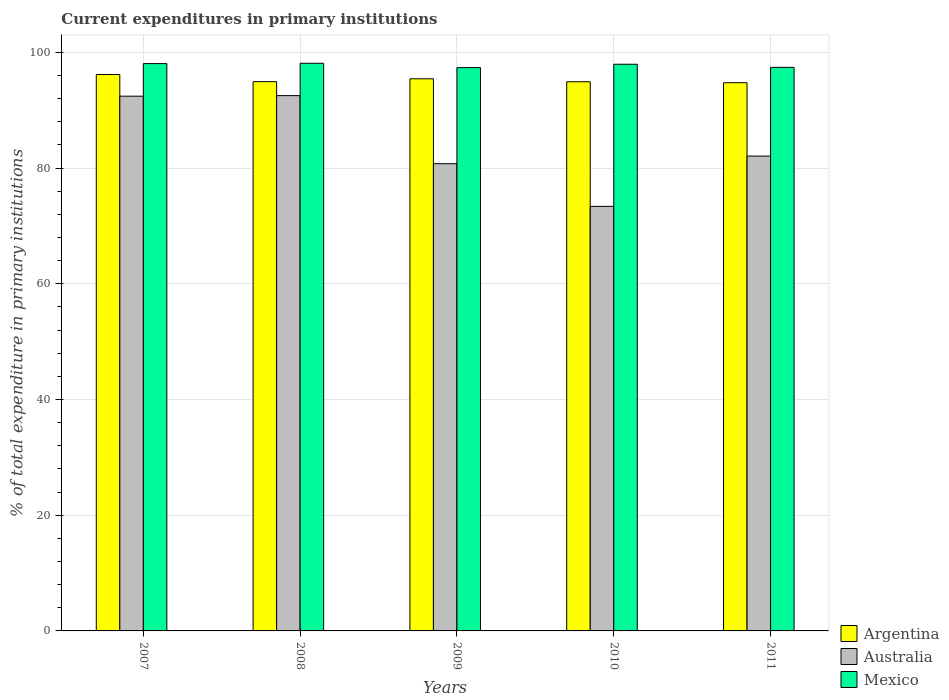Are the number of bars per tick equal to the number of legend labels?
Your answer should be compact. Yes. Are the number of bars on each tick of the X-axis equal?
Your response must be concise. Yes. How many bars are there on the 2nd tick from the left?
Your answer should be very brief. 3. How many bars are there on the 5th tick from the right?
Offer a terse response. 3. In how many cases, is the number of bars for a given year not equal to the number of legend labels?
Ensure brevity in your answer.  0. What is the current expenditures in primary institutions in Australia in 2011?
Ensure brevity in your answer.  82.07. Across all years, what is the maximum current expenditures in primary institutions in Mexico?
Your answer should be very brief. 98.11. Across all years, what is the minimum current expenditures in primary institutions in Australia?
Your answer should be very brief. 73.38. In which year was the current expenditures in primary institutions in Australia maximum?
Provide a short and direct response. 2008. What is the total current expenditures in primary institutions in Australia in the graph?
Make the answer very short. 421.15. What is the difference between the current expenditures in primary institutions in Mexico in 2008 and that in 2011?
Your response must be concise. 0.71. What is the difference between the current expenditures in primary institutions in Argentina in 2007 and the current expenditures in primary institutions in Mexico in 2010?
Offer a terse response. -1.77. What is the average current expenditures in primary institutions in Argentina per year?
Ensure brevity in your answer.  95.24. In the year 2011, what is the difference between the current expenditures in primary institutions in Argentina and current expenditures in primary institutions in Australia?
Your answer should be very brief. 12.68. What is the ratio of the current expenditures in primary institutions in Mexico in 2009 to that in 2011?
Make the answer very short. 1. Is the current expenditures in primary institutions in Australia in 2008 less than that in 2009?
Offer a very short reply. No. What is the difference between the highest and the second highest current expenditures in primary institutions in Argentina?
Provide a succinct answer. 0.74. What is the difference between the highest and the lowest current expenditures in primary institutions in Mexico?
Your answer should be very brief. 0.75. Is the sum of the current expenditures in primary institutions in Australia in 2008 and 2010 greater than the maximum current expenditures in primary institutions in Argentina across all years?
Offer a very short reply. Yes. What does the 2nd bar from the right in 2008 represents?
Provide a short and direct response. Australia. Is it the case that in every year, the sum of the current expenditures in primary institutions in Mexico and current expenditures in primary institutions in Argentina is greater than the current expenditures in primary institutions in Australia?
Provide a short and direct response. Yes. Are all the bars in the graph horizontal?
Give a very brief answer. No. How many years are there in the graph?
Your answer should be very brief. 5. Does the graph contain grids?
Provide a short and direct response. Yes. Where does the legend appear in the graph?
Your response must be concise. Bottom right. How many legend labels are there?
Ensure brevity in your answer.  3. How are the legend labels stacked?
Ensure brevity in your answer.  Vertical. What is the title of the graph?
Your answer should be very brief. Current expenditures in primary institutions. What is the label or title of the X-axis?
Keep it short and to the point. Years. What is the label or title of the Y-axis?
Offer a terse response. % of total expenditure in primary institutions. What is the % of total expenditure in primary institutions of Argentina in 2007?
Provide a succinct answer. 96.17. What is the % of total expenditure in primary institutions in Australia in 2007?
Keep it short and to the point. 92.42. What is the % of total expenditure in primary institutions of Mexico in 2007?
Ensure brevity in your answer.  98.05. What is the % of total expenditure in primary institutions of Argentina in 2008?
Provide a short and direct response. 94.93. What is the % of total expenditure in primary institutions in Australia in 2008?
Offer a very short reply. 92.52. What is the % of total expenditure in primary institutions of Mexico in 2008?
Your answer should be very brief. 98.11. What is the % of total expenditure in primary institutions of Argentina in 2009?
Provide a short and direct response. 95.43. What is the % of total expenditure in primary institutions in Australia in 2009?
Make the answer very short. 80.75. What is the % of total expenditure in primary institutions in Mexico in 2009?
Provide a succinct answer. 97.36. What is the % of total expenditure in primary institutions in Argentina in 2010?
Give a very brief answer. 94.92. What is the % of total expenditure in primary institutions of Australia in 2010?
Your response must be concise. 73.38. What is the % of total expenditure in primary institutions of Mexico in 2010?
Make the answer very short. 97.94. What is the % of total expenditure in primary institutions in Argentina in 2011?
Give a very brief answer. 94.75. What is the % of total expenditure in primary institutions of Australia in 2011?
Your response must be concise. 82.07. What is the % of total expenditure in primary institutions in Mexico in 2011?
Make the answer very short. 97.4. Across all years, what is the maximum % of total expenditure in primary institutions of Argentina?
Make the answer very short. 96.17. Across all years, what is the maximum % of total expenditure in primary institutions of Australia?
Offer a very short reply. 92.52. Across all years, what is the maximum % of total expenditure in primary institutions of Mexico?
Ensure brevity in your answer.  98.11. Across all years, what is the minimum % of total expenditure in primary institutions in Argentina?
Offer a very short reply. 94.75. Across all years, what is the minimum % of total expenditure in primary institutions of Australia?
Keep it short and to the point. 73.38. Across all years, what is the minimum % of total expenditure in primary institutions of Mexico?
Make the answer very short. 97.36. What is the total % of total expenditure in primary institutions in Argentina in the graph?
Offer a very short reply. 476.2. What is the total % of total expenditure in primary institutions of Australia in the graph?
Provide a short and direct response. 421.15. What is the total % of total expenditure in primary institutions of Mexico in the graph?
Make the answer very short. 488.87. What is the difference between the % of total expenditure in primary institutions of Argentina in 2007 and that in 2008?
Provide a short and direct response. 1.23. What is the difference between the % of total expenditure in primary institutions of Australia in 2007 and that in 2008?
Offer a terse response. -0.1. What is the difference between the % of total expenditure in primary institutions of Mexico in 2007 and that in 2008?
Give a very brief answer. -0.06. What is the difference between the % of total expenditure in primary institutions in Argentina in 2007 and that in 2009?
Offer a terse response. 0.74. What is the difference between the % of total expenditure in primary institutions of Australia in 2007 and that in 2009?
Your response must be concise. 11.67. What is the difference between the % of total expenditure in primary institutions in Mexico in 2007 and that in 2009?
Give a very brief answer. 0.69. What is the difference between the % of total expenditure in primary institutions in Argentina in 2007 and that in 2010?
Provide a succinct answer. 1.25. What is the difference between the % of total expenditure in primary institutions in Australia in 2007 and that in 2010?
Keep it short and to the point. 19.04. What is the difference between the % of total expenditure in primary institutions of Mexico in 2007 and that in 2010?
Provide a short and direct response. 0.11. What is the difference between the % of total expenditure in primary institutions of Argentina in 2007 and that in 2011?
Offer a terse response. 1.42. What is the difference between the % of total expenditure in primary institutions of Australia in 2007 and that in 2011?
Give a very brief answer. 10.35. What is the difference between the % of total expenditure in primary institutions of Mexico in 2007 and that in 2011?
Your answer should be compact. 0.65. What is the difference between the % of total expenditure in primary institutions of Argentina in 2008 and that in 2009?
Your answer should be compact. -0.5. What is the difference between the % of total expenditure in primary institutions in Australia in 2008 and that in 2009?
Give a very brief answer. 11.77. What is the difference between the % of total expenditure in primary institutions in Mexico in 2008 and that in 2009?
Keep it short and to the point. 0.75. What is the difference between the % of total expenditure in primary institutions in Argentina in 2008 and that in 2010?
Make the answer very short. 0.01. What is the difference between the % of total expenditure in primary institutions of Australia in 2008 and that in 2010?
Give a very brief answer. 19.14. What is the difference between the % of total expenditure in primary institutions in Mexico in 2008 and that in 2010?
Ensure brevity in your answer.  0.17. What is the difference between the % of total expenditure in primary institutions of Argentina in 2008 and that in 2011?
Your answer should be very brief. 0.19. What is the difference between the % of total expenditure in primary institutions in Australia in 2008 and that in 2011?
Provide a short and direct response. 10.45. What is the difference between the % of total expenditure in primary institutions in Mexico in 2008 and that in 2011?
Provide a short and direct response. 0.71. What is the difference between the % of total expenditure in primary institutions in Argentina in 2009 and that in 2010?
Provide a succinct answer. 0.51. What is the difference between the % of total expenditure in primary institutions of Australia in 2009 and that in 2010?
Give a very brief answer. 7.38. What is the difference between the % of total expenditure in primary institutions in Mexico in 2009 and that in 2010?
Provide a succinct answer. -0.58. What is the difference between the % of total expenditure in primary institutions of Argentina in 2009 and that in 2011?
Keep it short and to the point. 0.68. What is the difference between the % of total expenditure in primary institutions of Australia in 2009 and that in 2011?
Make the answer very short. -1.31. What is the difference between the % of total expenditure in primary institutions of Mexico in 2009 and that in 2011?
Offer a very short reply. -0.04. What is the difference between the % of total expenditure in primary institutions of Argentina in 2010 and that in 2011?
Your answer should be compact. 0.17. What is the difference between the % of total expenditure in primary institutions of Australia in 2010 and that in 2011?
Your answer should be very brief. -8.69. What is the difference between the % of total expenditure in primary institutions in Mexico in 2010 and that in 2011?
Provide a short and direct response. 0.54. What is the difference between the % of total expenditure in primary institutions in Argentina in 2007 and the % of total expenditure in primary institutions in Australia in 2008?
Give a very brief answer. 3.65. What is the difference between the % of total expenditure in primary institutions in Argentina in 2007 and the % of total expenditure in primary institutions in Mexico in 2008?
Ensure brevity in your answer.  -1.94. What is the difference between the % of total expenditure in primary institutions of Australia in 2007 and the % of total expenditure in primary institutions of Mexico in 2008?
Provide a short and direct response. -5.69. What is the difference between the % of total expenditure in primary institutions of Argentina in 2007 and the % of total expenditure in primary institutions of Australia in 2009?
Provide a short and direct response. 15.41. What is the difference between the % of total expenditure in primary institutions of Argentina in 2007 and the % of total expenditure in primary institutions of Mexico in 2009?
Offer a very short reply. -1.19. What is the difference between the % of total expenditure in primary institutions of Australia in 2007 and the % of total expenditure in primary institutions of Mexico in 2009?
Keep it short and to the point. -4.94. What is the difference between the % of total expenditure in primary institutions of Argentina in 2007 and the % of total expenditure in primary institutions of Australia in 2010?
Make the answer very short. 22.79. What is the difference between the % of total expenditure in primary institutions of Argentina in 2007 and the % of total expenditure in primary institutions of Mexico in 2010?
Provide a succinct answer. -1.77. What is the difference between the % of total expenditure in primary institutions of Australia in 2007 and the % of total expenditure in primary institutions of Mexico in 2010?
Offer a terse response. -5.52. What is the difference between the % of total expenditure in primary institutions in Argentina in 2007 and the % of total expenditure in primary institutions in Australia in 2011?
Your response must be concise. 14.1. What is the difference between the % of total expenditure in primary institutions in Argentina in 2007 and the % of total expenditure in primary institutions in Mexico in 2011?
Offer a terse response. -1.24. What is the difference between the % of total expenditure in primary institutions of Australia in 2007 and the % of total expenditure in primary institutions of Mexico in 2011?
Provide a short and direct response. -4.98. What is the difference between the % of total expenditure in primary institutions in Argentina in 2008 and the % of total expenditure in primary institutions in Australia in 2009?
Keep it short and to the point. 14.18. What is the difference between the % of total expenditure in primary institutions of Argentina in 2008 and the % of total expenditure in primary institutions of Mexico in 2009?
Ensure brevity in your answer.  -2.43. What is the difference between the % of total expenditure in primary institutions in Australia in 2008 and the % of total expenditure in primary institutions in Mexico in 2009?
Your response must be concise. -4.84. What is the difference between the % of total expenditure in primary institutions of Argentina in 2008 and the % of total expenditure in primary institutions of Australia in 2010?
Keep it short and to the point. 21.55. What is the difference between the % of total expenditure in primary institutions in Argentina in 2008 and the % of total expenditure in primary institutions in Mexico in 2010?
Keep it short and to the point. -3.01. What is the difference between the % of total expenditure in primary institutions of Australia in 2008 and the % of total expenditure in primary institutions of Mexico in 2010?
Offer a terse response. -5.42. What is the difference between the % of total expenditure in primary institutions in Argentina in 2008 and the % of total expenditure in primary institutions in Australia in 2011?
Provide a short and direct response. 12.86. What is the difference between the % of total expenditure in primary institutions in Argentina in 2008 and the % of total expenditure in primary institutions in Mexico in 2011?
Provide a short and direct response. -2.47. What is the difference between the % of total expenditure in primary institutions of Australia in 2008 and the % of total expenditure in primary institutions of Mexico in 2011?
Keep it short and to the point. -4.88. What is the difference between the % of total expenditure in primary institutions in Argentina in 2009 and the % of total expenditure in primary institutions in Australia in 2010?
Provide a succinct answer. 22.05. What is the difference between the % of total expenditure in primary institutions of Argentina in 2009 and the % of total expenditure in primary institutions of Mexico in 2010?
Ensure brevity in your answer.  -2.51. What is the difference between the % of total expenditure in primary institutions in Australia in 2009 and the % of total expenditure in primary institutions in Mexico in 2010?
Make the answer very short. -17.19. What is the difference between the % of total expenditure in primary institutions of Argentina in 2009 and the % of total expenditure in primary institutions of Australia in 2011?
Keep it short and to the point. 13.36. What is the difference between the % of total expenditure in primary institutions in Argentina in 2009 and the % of total expenditure in primary institutions in Mexico in 2011?
Offer a terse response. -1.97. What is the difference between the % of total expenditure in primary institutions of Australia in 2009 and the % of total expenditure in primary institutions of Mexico in 2011?
Ensure brevity in your answer.  -16.65. What is the difference between the % of total expenditure in primary institutions of Argentina in 2010 and the % of total expenditure in primary institutions of Australia in 2011?
Your answer should be very brief. 12.85. What is the difference between the % of total expenditure in primary institutions in Argentina in 2010 and the % of total expenditure in primary institutions in Mexico in 2011?
Your response must be concise. -2.48. What is the difference between the % of total expenditure in primary institutions in Australia in 2010 and the % of total expenditure in primary institutions in Mexico in 2011?
Ensure brevity in your answer.  -24.02. What is the average % of total expenditure in primary institutions of Argentina per year?
Give a very brief answer. 95.24. What is the average % of total expenditure in primary institutions in Australia per year?
Your answer should be very brief. 84.23. What is the average % of total expenditure in primary institutions in Mexico per year?
Offer a very short reply. 97.77. In the year 2007, what is the difference between the % of total expenditure in primary institutions in Argentina and % of total expenditure in primary institutions in Australia?
Give a very brief answer. 3.75. In the year 2007, what is the difference between the % of total expenditure in primary institutions of Argentina and % of total expenditure in primary institutions of Mexico?
Provide a short and direct response. -1.88. In the year 2007, what is the difference between the % of total expenditure in primary institutions of Australia and % of total expenditure in primary institutions of Mexico?
Offer a very short reply. -5.63. In the year 2008, what is the difference between the % of total expenditure in primary institutions of Argentina and % of total expenditure in primary institutions of Australia?
Make the answer very short. 2.41. In the year 2008, what is the difference between the % of total expenditure in primary institutions of Argentina and % of total expenditure in primary institutions of Mexico?
Give a very brief answer. -3.18. In the year 2008, what is the difference between the % of total expenditure in primary institutions of Australia and % of total expenditure in primary institutions of Mexico?
Ensure brevity in your answer.  -5.59. In the year 2009, what is the difference between the % of total expenditure in primary institutions of Argentina and % of total expenditure in primary institutions of Australia?
Provide a succinct answer. 14.67. In the year 2009, what is the difference between the % of total expenditure in primary institutions of Argentina and % of total expenditure in primary institutions of Mexico?
Your answer should be compact. -1.93. In the year 2009, what is the difference between the % of total expenditure in primary institutions of Australia and % of total expenditure in primary institutions of Mexico?
Make the answer very short. -16.61. In the year 2010, what is the difference between the % of total expenditure in primary institutions of Argentina and % of total expenditure in primary institutions of Australia?
Provide a succinct answer. 21.54. In the year 2010, what is the difference between the % of total expenditure in primary institutions in Argentina and % of total expenditure in primary institutions in Mexico?
Your answer should be compact. -3.02. In the year 2010, what is the difference between the % of total expenditure in primary institutions in Australia and % of total expenditure in primary institutions in Mexico?
Your answer should be compact. -24.56. In the year 2011, what is the difference between the % of total expenditure in primary institutions of Argentina and % of total expenditure in primary institutions of Australia?
Your answer should be very brief. 12.68. In the year 2011, what is the difference between the % of total expenditure in primary institutions in Argentina and % of total expenditure in primary institutions in Mexico?
Offer a terse response. -2.66. In the year 2011, what is the difference between the % of total expenditure in primary institutions in Australia and % of total expenditure in primary institutions in Mexico?
Offer a very short reply. -15.33. What is the ratio of the % of total expenditure in primary institutions of Argentina in 2007 to that in 2009?
Your response must be concise. 1.01. What is the ratio of the % of total expenditure in primary institutions in Australia in 2007 to that in 2009?
Ensure brevity in your answer.  1.14. What is the ratio of the % of total expenditure in primary institutions in Mexico in 2007 to that in 2009?
Your response must be concise. 1.01. What is the ratio of the % of total expenditure in primary institutions of Argentina in 2007 to that in 2010?
Make the answer very short. 1.01. What is the ratio of the % of total expenditure in primary institutions of Australia in 2007 to that in 2010?
Offer a very short reply. 1.26. What is the ratio of the % of total expenditure in primary institutions in Mexico in 2007 to that in 2010?
Give a very brief answer. 1. What is the ratio of the % of total expenditure in primary institutions of Argentina in 2007 to that in 2011?
Provide a short and direct response. 1.01. What is the ratio of the % of total expenditure in primary institutions in Australia in 2007 to that in 2011?
Your response must be concise. 1.13. What is the ratio of the % of total expenditure in primary institutions of Australia in 2008 to that in 2009?
Keep it short and to the point. 1.15. What is the ratio of the % of total expenditure in primary institutions of Mexico in 2008 to that in 2009?
Ensure brevity in your answer.  1.01. What is the ratio of the % of total expenditure in primary institutions of Australia in 2008 to that in 2010?
Offer a very short reply. 1.26. What is the ratio of the % of total expenditure in primary institutions of Mexico in 2008 to that in 2010?
Provide a short and direct response. 1. What is the ratio of the % of total expenditure in primary institutions in Australia in 2008 to that in 2011?
Provide a short and direct response. 1.13. What is the ratio of the % of total expenditure in primary institutions of Mexico in 2008 to that in 2011?
Your response must be concise. 1.01. What is the ratio of the % of total expenditure in primary institutions in Argentina in 2009 to that in 2010?
Make the answer very short. 1.01. What is the ratio of the % of total expenditure in primary institutions of Australia in 2009 to that in 2010?
Keep it short and to the point. 1.1. What is the ratio of the % of total expenditure in primary institutions in Australia in 2009 to that in 2011?
Make the answer very short. 0.98. What is the ratio of the % of total expenditure in primary institutions of Mexico in 2009 to that in 2011?
Your response must be concise. 1. What is the ratio of the % of total expenditure in primary institutions in Argentina in 2010 to that in 2011?
Keep it short and to the point. 1. What is the ratio of the % of total expenditure in primary institutions of Australia in 2010 to that in 2011?
Your answer should be compact. 0.89. What is the difference between the highest and the second highest % of total expenditure in primary institutions in Argentina?
Offer a very short reply. 0.74. What is the difference between the highest and the second highest % of total expenditure in primary institutions of Australia?
Make the answer very short. 0.1. What is the difference between the highest and the second highest % of total expenditure in primary institutions of Mexico?
Give a very brief answer. 0.06. What is the difference between the highest and the lowest % of total expenditure in primary institutions of Argentina?
Your answer should be compact. 1.42. What is the difference between the highest and the lowest % of total expenditure in primary institutions of Australia?
Offer a terse response. 19.14. What is the difference between the highest and the lowest % of total expenditure in primary institutions of Mexico?
Your answer should be compact. 0.75. 